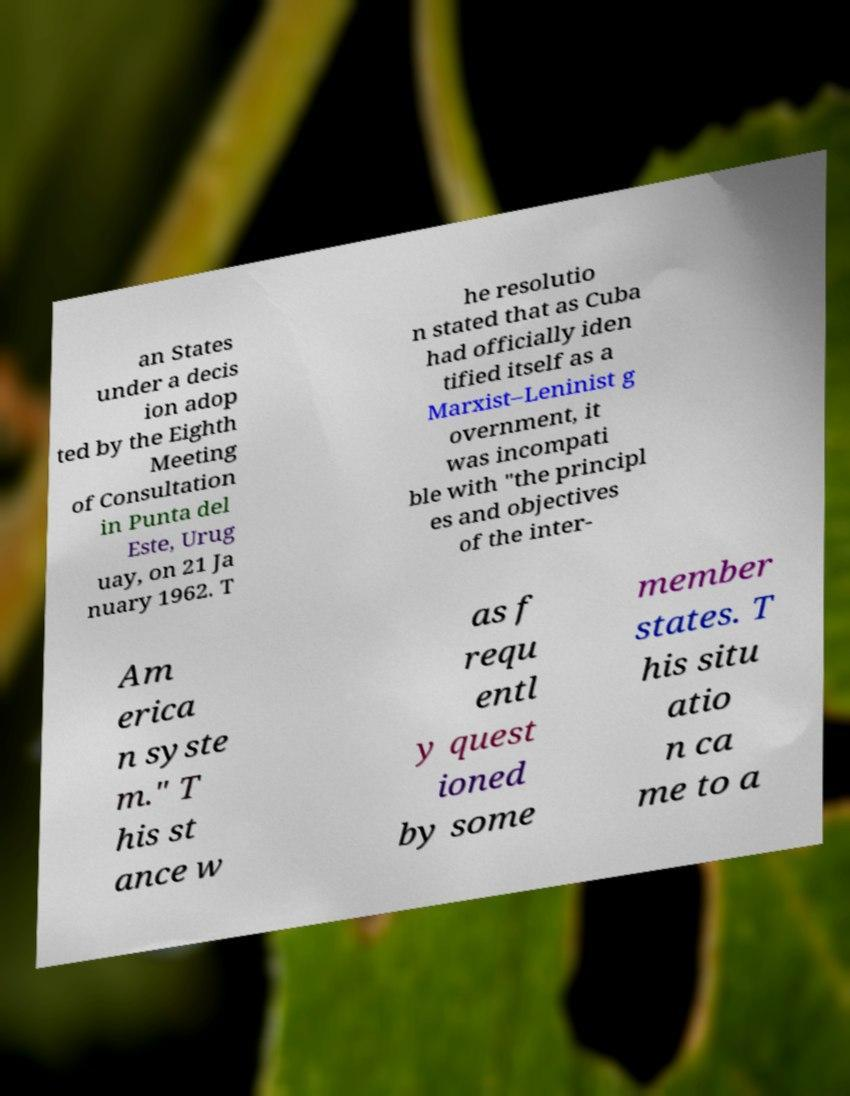There's text embedded in this image that I need extracted. Can you transcribe it verbatim? an States under a decis ion adop ted by the Eighth Meeting of Consultation in Punta del Este, Urug uay, on 21 Ja nuary 1962. T he resolutio n stated that as Cuba had officially iden tified itself as a Marxist–Leninist g overnment, it was incompati ble with "the principl es and objectives of the inter- Am erica n syste m." T his st ance w as f requ entl y quest ioned by some member states. T his situ atio n ca me to a 